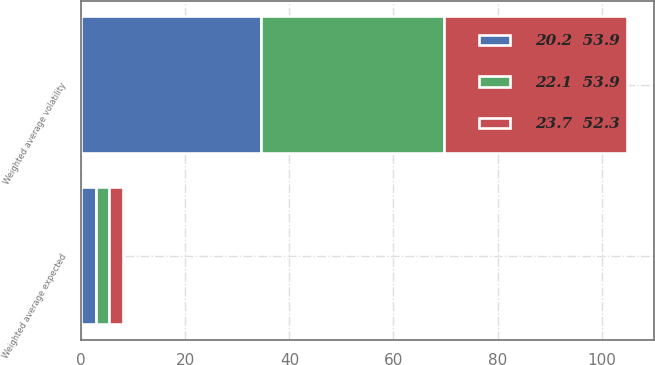Convert chart to OTSL. <chart><loc_0><loc_0><loc_500><loc_500><stacked_bar_chart><ecel><fcel>Weighted average volatility<fcel>Weighted average expected<nl><fcel>20.2  53.9<fcel>34.6<fcel>2.8<nl><fcel>23.7  52.3<fcel>35.1<fcel>2.7<nl><fcel>22.1  53.9<fcel>35.1<fcel>2.6<nl></chart> 